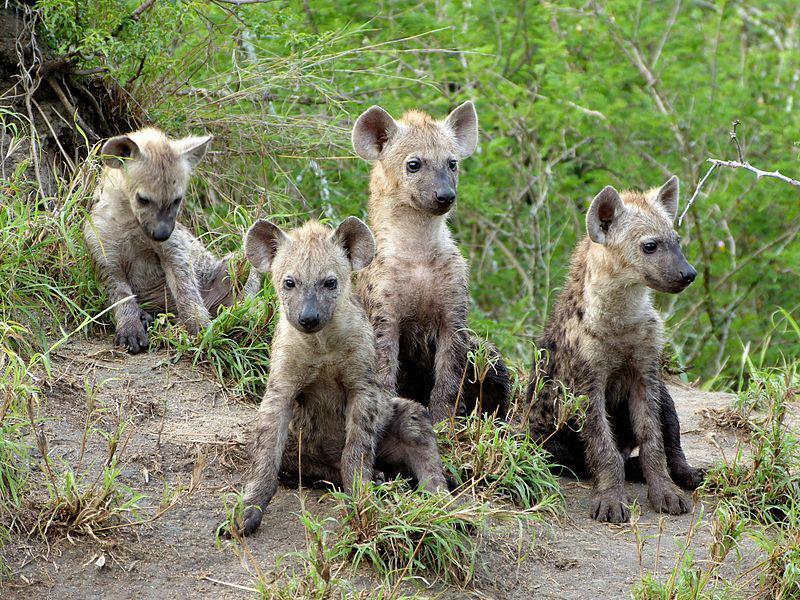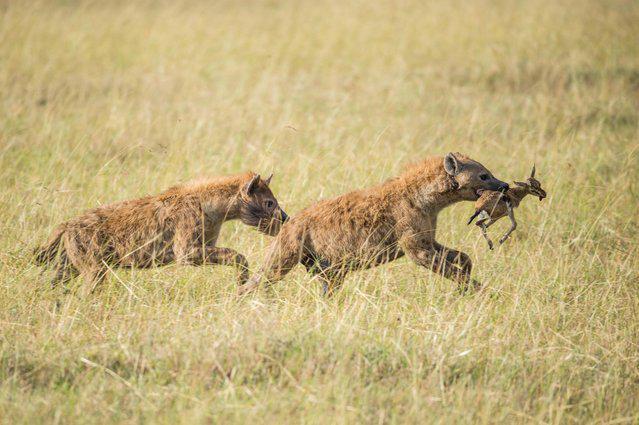The first image is the image on the left, the second image is the image on the right. Given the left and right images, does the statement "One image contains a single hyena." hold true? Answer yes or no. No. 